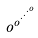<formula> <loc_0><loc_0><loc_500><loc_500>o ^ { o ^ { \cdot ^ { \cdot ^ { \cdot ^ { o } } } } }</formula> 